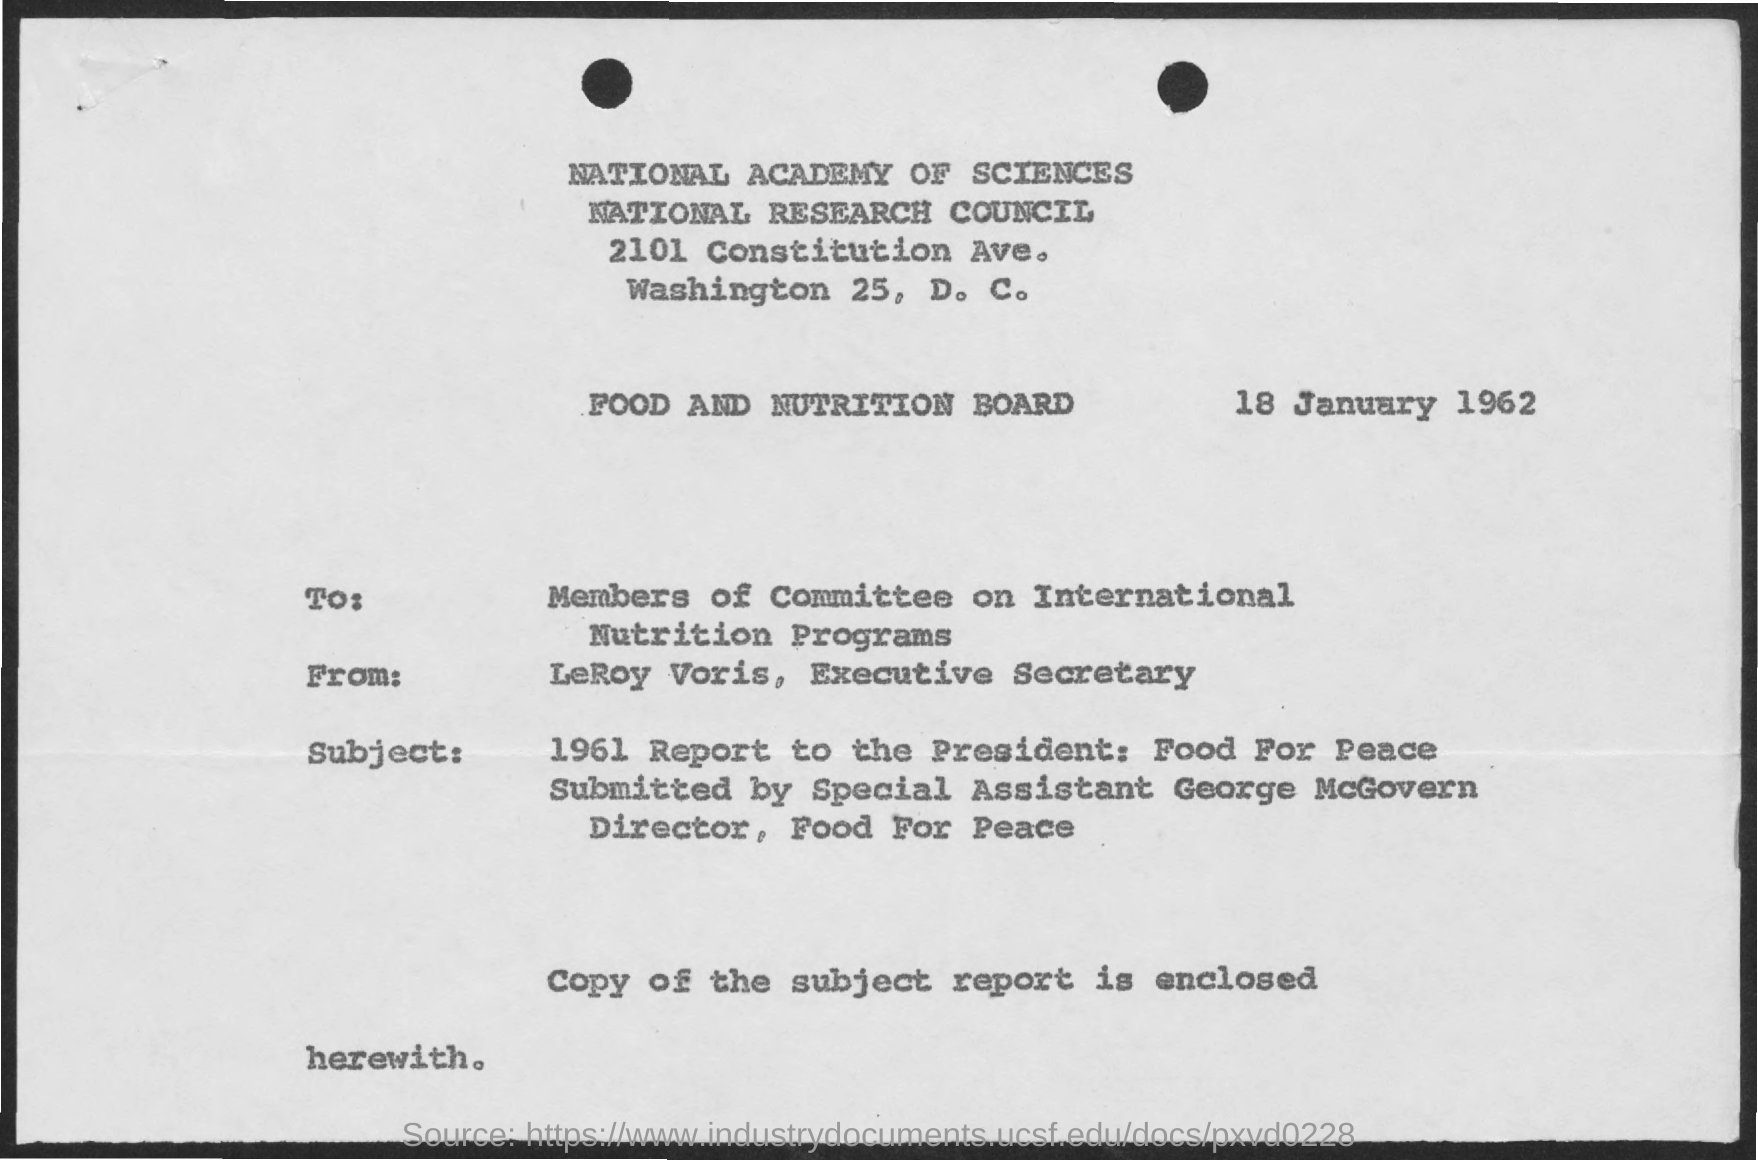Give some essential details in this illustration. LeRoy Voris, the Executive Secretary, is the sender of this document. The enclosed document contains a copy of the subject report. The document is directed to the members of the Committee on International Nutrition Programs. The date mentioned in this document is 18 January 1962. 